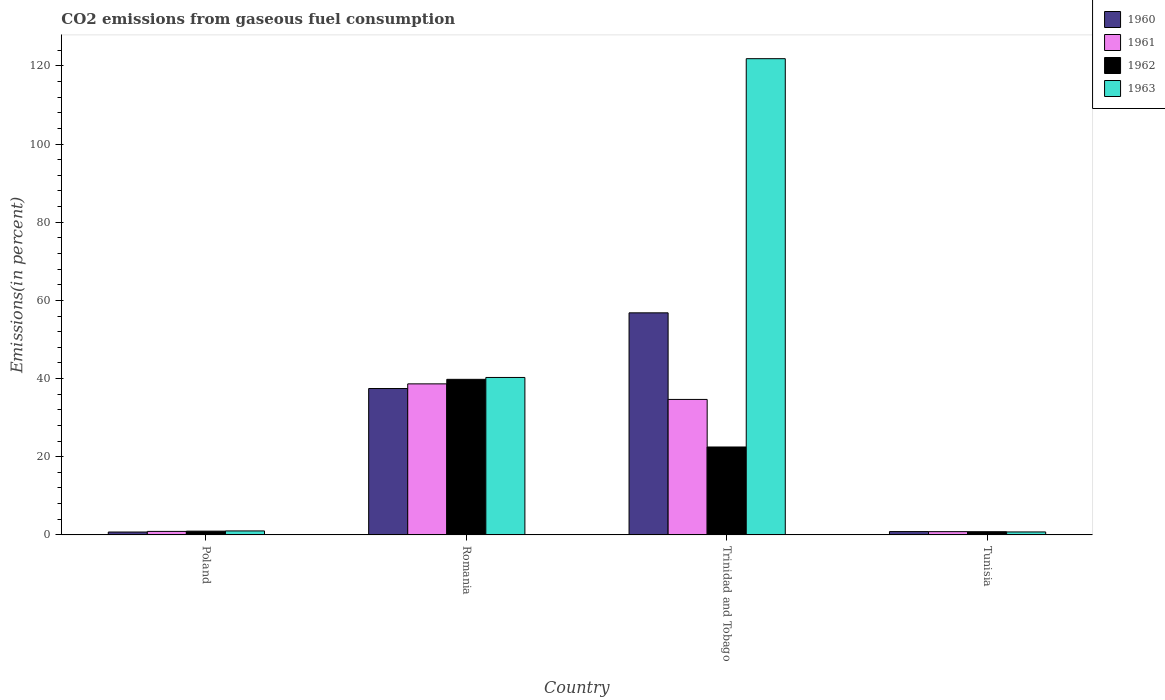How many different coloured bars are there?
Offer a very short reply. 4. How many groups of bars are there?
Offer a terse response. 4. Are the number of bars per tick equal to the number of legend labels?
Your answer should be compact. Yes. How many bars are there on the 1st tick from the right?
Give a very brief answer. 4. What is the label of the 3rd group of bars from the left?
Offer a terse response. Trinidad and Tobago. In how many cases, is the number of bars for a given country not equal to the number of legend labels?
Offer a very short reply. 0. What is the total CO2 emitted in 1963 in Trinidad and Tobago?
Offer a very short reply. 121.85. Across all countries, what is the maximum total CO2 emitted in 1961?
Ensure brevity in your answer.  38.65. Across all countries, what is the minimum total CO2 emitted in 1962?
Your response must be concise. 0.82. In which country was the total CO2 emitted in 1960 maximum?
Your answer should be very brief. Trinidad and Tobago. In which country was the total CO2 emitted in 1962 minimum?
Your answer should be compact. Tunisia. What is the total total CO2 emitted in 1962 in the graph?
Your answer should be very brief. 64.07. What is the difference between the total CO2 emitted in 1962 in Poland and that in Tunisia?
Your answer should be compact. 0.14. What is the difference between the total CO2 emitted in 1961 in Trinidad and Tobago and the total CO2 emitted in 1963 in Romania?
Your response must be concise. -5.62. What is the average total CO2 emitted in 1962 per country?
Offer a very short reply. 16.02. What is the difference between the total CO2 emitted of/in 1963 and total CO2 emitted of/in 1961 in Tunisia?
Your answer should be very brief. -0.08. What is the ratio of the total CO2 emitted in 1963 in Trinidad and Tobago to that in Tunisia?
Offer a terse response. 161.75. What is the difference between the highest and the second highest total CO2 emitted in 1960?
Your response must be concise. 55.97. What is the difference between the highest and the lowest total CO2 emitted in 1960?
Your response must be concise. 56.08. In how many countries, is the total CO2 emitted in 1962 greater than the average total CO2 emitted in 1962 taken over all countries?
Your answer should be very brief. 2. Is it the case that in every country, the sum of the total CO2 emitted in 1961 and total CO2 emitted in 1962 is greater than the sum of total CO2 emitted in 1963 and total CO2 emitted in 1960?
Keep it short and to the point. No. What does the 4th bar from the left in Tunisia represents?
Keep it short and to the point. 1963. What does the 3rd bar from the right in Tunisia represents?
Keep it short and to the point. 1961. How many bars are there?
Keep it short and to the point. 16. Are all the bars in the graph horizontal?
Offer a terse response. No. How many countries are there in the graph?
Your response must be concise. 4. Are the values on the major ticks of Y-axis written in scientific E-notation?
Make the answer very short. No. Does the graph contain any zero values?
Make the answer very short. No. Where does the legend appear in the graph?
Your response must be concise. Top right. What is the title of the graph?
Give a very brief answer. CO2 emissions from gaseous fuel consumption. Does "1982" appear as one of the legend labels in the graph?
Your response must be concise. No. What is the label or title of the Y-axis?
Provide a succinct answer. Emissions(in percent). What is the Emissions(in percent) in 1960 in Poland?
Give a very brief answer. 0.74. What is the Emissions(in percent) of 1961 in Poland?
Ensure brevity in your answer.  0.89. What is the Emissions(in percent) in 1962 in Poland?
Give a very brief answer. 0.96. What is the Emissions(in percent) of 1963 in Poland?
Make the answer very short. 1.01. What is the Emissions(in percent) of 1960 in Romania?
Keep it short and to the point. 37.45. What is the Emissions(in percent) in 1961 in Romania?
Offer a very short reply. 38.65. What is the Emissions(in percent) of 1962 in Romania?
Your answer should be compact. 39.8. What is the Emissions(in percent) of 1963 in Romania?
Offer a very short reply. 40.28. What is the Emissions(in percent) in 1960 in Trinidad and Tobago?
Provide a succinct answer. 56.82. What is the Emissions(in percent) of 1961 in Trinidad and Tobago?
Provide a short and direct response. 34.66. What is the Emissions(in percent) in 1962 in Trinidad and Tobago?
Offer a very short reply. 22.49. What is the Emissions(in percent) of 1963 in Trinidad and Tobago?
Ensure brevity in your answer.  121.85. What is the Emissions(in percent) of 1960 in Tunisia?
Offer a terse response. 0.85. What is the Emissions(in percent) of 1961 in Tunisia?
Give a very brief answer. 0.83. What is the Emissions(in percent) in 1962 in Tunisia?
Make the answer very short. 0.82. What is the Emissions(in percent) of 1963 in Tunisia?
Make the answer very short. 0.75. Across all countries, what is the maximum Emissions(in percent) in 1960?
Ensure brevity in your answer.  56.82. Across all countries, what is the maximum Emissions(in percent) in 1961?
Your answer should be very brief. 38.65. Across all countries, what is the maximum Emissions(in percent) of 1962?
Your answer should be very brief. 39.8. Across all countries, what is the maximum Emissions(in percent) in 1963?
Your answer should be compact. 121.85. Across all countries, what is the minimum Emissions(in percent) in 1960?
Offer a terse response. 0.74. Across all countries, what is the minimum Emissions(in percent) in 1961?
Your response must be concise. 0.83. Across all countries, what is the minimum Emissions(in percent) of 1962?
Make the answer very short. 0.82. Across all countries, what is the minimum Emissions(in percent) in 1963?
Your response must be concise. 0.75. What is the total Emissions(in percent) of 1960 in the graph?
Offer a very short reply. 95.86. What is the total Emissions(in percent) in 1961 in the graph?
Your response must be concise. 75.03. What is the total Emissions(in percent) in 1962 in the graph?
Provide a succinct answer. 64.07. What is the total Emissions(in percent) in 1963 in the graph?
Offer a terse response. 163.9. What is the difference between the Emissions(in percent) in 1960 in Poland and that in Romania?
Provide a short and direct response. -36.72. What is the difference between the Emissions(in percent) of 1961 in Poland and that in Romania?
Offer a terse response. -37.75. What is the difference between the Emissions(in percent) of 1962 in Poland and that in Romania?
Your answer should be compact. -38.85. What is the difference between the Emissions(in percent) in 1963 in Poland and that in Romania?
Offer a terse response. -39.27. What is the difference between the Emissions(in percent) of 1960 in Poland and that in Trinidad and Tobago?
Keep it short and to the point. -56.08. What is the difference between the Emissions(in percent) in 1961 in Poland and that in Trinidad and Tobago?
Offer a terse response. -33.77. What is the difference between the Emissions(in percent) in 1962 in Poland and that in Trinidad and Tobago?
Give a very brief answer. -21.53. What is the difference between the Emissions(in percent) in 1963 in Poland and that in Trinidad and Tobago?
Keep it short and to the point. -120.84. What is the difference between the Emissions(in percent) in 1960 in Poland and that in Tunisia?
Your answer should be compact. -0.11. What is the difference between the Emissions(in percent) in 1961 in Poland and that in Tunisia?
Your answer should be compact. 0.06. What is the difference between the Emissions(in percent) in 1962 in Poland and that in Tunisia?
Make the answer very short. 0.14. What is the difference between the Emissions(in percent) in 1963 in Poland and that in Tunisia?
Your answer should be very brief. 0.26. What is the difference between the Emissions(in percent) in 1960 in Romania and that in Trinidad and Tobago?
Provide a succinct answer. -19.37. What is the difference between the Emissions(in percent) of 1961 in Romania and that in Trinidad and Tobago?
Your answer should be compact. 3.98. What is the difference between the Emissions(in percent) of 1962 in Romania and that in Trinidad and Tobago?
Keep it short and to the point. 17.31. What is the difference between the Emissions(in percent) in 1963 in Romania and that in Trinidad and Tobago?
Ensure brevity in your answer.  -81.57. What is the difference between the Emissions(in percent) in 1960 in Romania and that in Tunisia?
Keep it short and to the point. 36.6. What is the difference between the Emissions(in percent) in 1961 in Romania and that in Tunisia?
Your answer should be very brief. 37.82. What is the difference between the Emissions(in percent) in 1962 in Romania and that in Tunisia?
Your response must be concise. 38.99. What is the difference between the Emissions(in percent) in 1963 in Romania and that in Tunisia?
Ensure brevity in your answer.  39.53. What is the difference between the Emissions(in percent) of 1960 in Trinidad and Tobago and that in Tunisia?
Keep it short and to the point. 55.97. What is the difference between the Emissions(in percent) of 1961 in Trinidad and Tobago and that in Tunisia?
Keep it short and to the point. 33.83. What is the difference between the Emissions(in percent) in 1962 in Trinidad and Tobago and that in Tunisia?
Provide a short and direct response. 21.68. What is the difference between the Emissions(in percent) in 1963 in Trinidad and Tobago and that in Tunisia?
Keep it short and to the point. 121.1. What is the difference between the Emissions(in percent) in 1960 in Poland and the Emissions(in percent) in 1961 in Romania?
Provide a succinct answer. -37.91. What is the difference between the Emissions(in percent) in 1960 in Poland and the Emissions(in percent) in 1962 in Romania?
Give a very brief answer. -39.07. What is the difference between the Emissions(in percent) in 1960 in Poland and the Emissions(in percent) in 1963 in Romania?
Provide a short and direct response. -39.55. What is the difference between the Emissions(in percent) of 1961 in Poland and the Emissions(in percent) of 1962 in Romania?
Make the answer very short. -38.91. What is the difference between the Emissions(in percent) in 1961 in Poland and the Emissions(in percent) in 1963 in Romania?
Keep it short and to the point. -39.39. What is the difference between the Emissions(in percent) of 1962 in Poland and the Emissions(in percent) of 1963 in Romania?
Your response must be concise. -39.32. What is the difference between the Emissions(in percent) in 1960 in Poland and the Emissions(in percent) in 1961 in Trinidad and Tobago?
Offer a very short reply. -33.93. What is the difference between the Emissions(in percent) of 1960 in Poland and the Emissions(in percent) of 1962 in Trinidad and Tobago?
Give a very brief answer. -21.76. What is the difference between the Emissions(in percent) of 1960 in Poland and the Emissions(in percent) of 1963 in Trinidad and Tobago?
Your answer should be compact. -121.11. What is the difference between the Emissions(in percent) of 1961 in Poland and the Emissions(in percent) of 1962 in Trinidad and Tobago?
Keep it short and to the point. -21.6. What is the difference between the Emissions(in percent) of 1961 in Poland and the Emissions(in percent) of 1963 in Trinidad and Tobago?
Offer a very short reply. -120.95. What is the difference between the Emissions(in percent) in 1962 in Poland and the Emissions(in percent) in 1963 in Trinidad and Tobago?
Provide a short and direct response. -120.89. What is the difference between the Emissions(in percent) of 1960 in Poland and the Emissions(in percent) of 1961 in Tunisia?
Ensure brevity in your answer.  -0.09. What is the difference between the Emissions(in percent) in 1960 in Poland and the Emissions(in percent) in 1962 in Tunisia?
Ensure brevity in your answer.  -0.08. What is the difference between the Emissions(in percent) in 1960 in Poland and the Emissions(in percent) in 1963 in Tunisia?
Offer a very short reply. -0.02. What is the difference between the Emissions(in percent) in 1961 in Poland and the Emissions(in percent) in 1962 in Tunisia?
Your answer should be very brief. 0.08. What is the difference between the Emissions(in percent) of 1961 in Poland and the Emissions(in percent) of 1963 in Tunisia?
Your answer should be compact. 0.14. What is the difference between the Emissions(in percent) of 1962 in Poland and the Emissions(in percent) of 1963 in Tunisia?
Give a very brief answer. 0.21. What is the difference between the Emissions(in percent) of 1960 in Romania and the Emissions(in percent) of 1961 in Trinidad and Tobago?
Make the answer very short. 2.79. What is the difference between the Emissions(in percent) of 1960 in Romania and the Emissions(in percent) of 1962 in Trinidad and Tobago?
Provide a succinct answer. 14.96. What is the difference between the Emissions(in percent) in 1960 in Romania and the Emissions(in percent) in 1963 in Trinidad and Tobago?
Provide a short and direct response. -84.4. What is the difference between the Emissions(in percent) of 1961 in Romania and the Emissions(in percent) of 1962 in Trinidad and Tobago?
Ensure brevity in your answer.  16.15. What is the difference between the Emissions(in percent) in 1961 in Romania and the Emissions(in percent) in 1963 in Trinidad and Tobago?
Provide a short and direct response. -83.2. What is the difference between the Emissions(in percent) in 1962 in Romania and the Emissions(in percent) in 1963 in Trinidad and Tobago?
Make the answer very short. -82.04. What is the difference between the Emissions(in percent) of 1960 in Romania and the Emissions(in percent) of 1961 in Tunisia?
Keep it short and to the point. 36.62. What is the difference between the Emissions(in percent) in 1960 in Romania and the Emissions(in percent) in 1962 in Tunisia?
Provide a short and direct response. 36.64. What is the difference between the Emissions(in percent) in 1960 in Romania and the Emissions(in percent) in 1963 in Tunisia?
Provide a succinct answer. 36.7. What is the difference between the Emissions(in percent) in 1961 in Romania and the Emissions(in percent) in 1962 in Tunisia?
Offer a terse response. 37.83. What is the difference between the Emissions(in percent) in 1961 in Romania and the Emissions(in percent) in 1963 in Tunisia?
Your answer should be compact. 37.89. What is the difference between the Emissions(in percent) in 1962 in Romania and the Emissions(in percent) in 1963 in Tunisia?
Your response must be concise. 39.05. What is the difference between the Emissions(in percent) in 1960 in Trinidad and Tobago and the Emissions(in percent) in 1961 in Tunisia?
Your answer should be compact. 55.99. What is the difference between the Emissions(in percent) of 1960 in Trinidad and Tobago and the Emissions(in percent) of 1962 in Tunisia?
Your response must be concise. 56. What is the difference between the Emissions(in percent) in 1960 in Trinidad and Tobago and the Emissions(in percent) in 1963 in Tunisia?
Your response must be concise. 56.06. What is the difference between the Emissions(in percent) in 1961 in Trinidad and Tobago and the Emissions(in percent) in 1962 in Tunisia?
Offer a very short reply. 33.84. What is the difference between the Emissions(in percent) of 1961 in Trinidad and Tobago and the Emissions(in percent) of 1963 in Tunisia?
Ensure brevity in your answer.  33.91. What is the difference between the Emissions(in percent) in 1962 in Trinidad and Tobago and the Emissions(in percent) in 1963 in Tunisia?
Provide a short and direct response. 21.74. What is the average Emissions(in percent) of 1960 per country?
Offer a terse response. 23.96. What is the average Emissions(in percent) in 1961 per country?
Keep it short and to the point. 18.76. What is the average Emissions(in percent) in 1962 per country?
Offer a terse response. 16.02. What is the average Emissions(in percent) of 1963 per country?
Provide a short and direct response. 40.97. What is the difference between the Emissions(in percent) in 1960 and Emissions(in percent) in 1961 in Poland?
Provide a succinct answer. -0.16. What is the difference between the Emissions(in percent) in 1960 and Emissions(in percent) in 1962 in Poland?
Give a very brief answer. -0.22. What is the difference between the Emissions(in percent) of 1960 and Emissions(in percent) of 1963 in Poland?
Provide a short and direct response. -0.28. What is the difference between the Emissions(in percent) of 1961 and Emissions(in percent) of 1962 in Poland?
Give a very brief answer. -0.06. What is the difference between the Emissions(in percent) in 1961 and Emissions(in percent) in 1963 in Poland?
Provide a succinct answer. -0.12. What is the difference between the Emissions(in percent) in 1962 and Emissions(in percent) in 1963 in Poland?
Your answer should be very brief. -0.05. What is the difference between the Emissions(in percent) of 1960 and Emissions(in percent) of 1961 in Romania?
Make the answer very short. -1.19. What is the difference between the Emissions(in percent) of 1960 and Emissions(in percent) of 1962 in Romania?
Your response must be concise. -2.35. What is the difference between the Emissions(in percent) in 1960 and Emissions(in percent) in 1963 in Romania?
Your answer should be very brief. -2.83. What is the difference between the Emissions(in percent) of 1961 and Emissions(in percent) of 1962 in Romania?
Ensure brevity in your answer.  -1.16. What is the difference between the Emissions(in percent) in 1961 and Emissions(in percent) in 1963 in Romania?
Offer a terse response. -1.64. What is the difference between the Emissions(in percent) in 1962 and Emissions(in percent) in 1963 in Romania?
Provide a succinct answer. -0.48. What is the difference between the Emissions(in percent) in 1960 and Emissions(in percent) in 1961 in Trinidad and Tobago?
Your answer should be very brief. 22.16. What is the difference between the Emissions(in percent) in 1960 and Emissions(in percent) in 1962 in Trinidad and Tobago?
Provide a succinct answer. 34.33. What is the difference between the Emissions(in percent) of 1960 and Emissions(in percent) of 1963 in Trinidad and Tobago?
Ensure brevity in your answer.  -65.03. What is the difference between the Emissions(in percent) of 1961 and Emissions(in percent) of 1962 in Trinidad and Tobago?
Your answer should be compact. 12.17. What is the difference between the Emissions(in percent) of 1961 and Emissions(in percent) of 1963 in Trinidad and Tobago?
Your answer should be compact. -87.19. What is the difference between the Emissions(in percent) in 1962 and Emissions(in percent) in 1963 in Trinidad and Tobago?
Keep it short and to the point. -99.36. What is the difference between the Emissions(in percent) of 1960 and Emissions(in percent) of 1961 in Tunisia?
Provide a short and direct response. 0.02. What is the difference between the Emissions(in percent) in 1960 and Emissions(in percent) in 1962 in Tunisia?
Your answer should be very brief. 0.03. What is the difference between the Emissions(in percent) of 1960 and Emissions(in percent) of 1963 in Tunisia?
Keep it short and to the point. 0.1. What is the difference between the Emissions(in percent) in 1961 and Emissions(in percent) in 1962 in Tunisia?
Your answer should be compact. 0.01. What is the difference between the Emissions(in percent) of 1961 and Emissions(in percent) of 1963 in Tunisia?
Give a very brief answer. 0.08. What is the difference between the Emissions(in percent) in 1962 and Emissions(in percent) in 1963 in Tunisia?
Offer a very short reply. 0.06. What is the ratio of the Emissions(in percent) of 1960 in Poland to that in Romania?
Your response must be concise. 0.02. What is the ratio of the Emissions(in percent) of 1961 in Poland to that in Romania?
Keep it short and to the point. 0.02. What is the ratio of the Emissions(in percent) of 1962 in Poland to that in Romania?
Ensure brevity in your answer.  0.02. What is the ratio of the Emissions(in percent) in 1963 in Poland to that in Romania?
Make the answer very short. 0.03. What is the ratio of the Emissions(in percent) in 1960 in Poland to that in Trinidad and Tobago?
Provide a succinct answer. 0.01. What is the ratio of the Emissions(in percent) of 1961 in Poland to that in Trinidad and Tobago?
Your response must be concise. 0.03. What is the ratio of the Emissions(in percent) in 1962 in Poland to that in Trinidad and Tobago?
Ensure brevity in your answer.  0.04. What is the ratio of the Emissions(in percent) in 1963 in Poland to that in Trinidad and Tobago?
Keep it short and to the point. 0.01. What is the ratio of the Emissions(in percent) of 1960 in Poland to that in Tunisia?
Offer a very short reply. 0.87. What is the ratio of the Emissions(in percent) of 1961 in Poland to that in Tunisia?
Offer a terse response. 1.08. What is the ratio of the Emissions(in percent) of 1962 in Poland to that in Tunisia?
Make the answer very short. 1.17. What is the ratio of the Emissions(in percent) in 1963 in Poland to that in Tunisia?
Your response must be concise. 1.35. What is the ratio of the Emissions(in percent) in 1960 in Romania to that in Trinidad and Tobago?
Ensure brevity in your answer.  0.66. What is the ratio of the Emissions(in percent) in 1961 in Romania to that in Trinidad and Tobago?
Keep it short and to the point. 1.11. What is the ratio of the Emissions(in percent) in 1962 in Romania to that in Trinidad and Tobago?
Provide a succinct answer. 1.77. What is the ratio of the Emissions(in percent) in 1963 in Romania to that in Trinidad and Tobago?
Make the answer very short. 0.33. What is the ratio of the Emissions(in percent) of 1960 in Romania to that in Tunisia?
Make the answer very short. 44.1. What is the ratio of the Emissions(in percent) of 1961 in Romania to that in Tunisia?
Your answer should be very brief. 46.57. What is the ratio of the Emissions(in percent) of 1962 in Romania to that in Tunisia?
Provide a succinct answer. 48.76. What is the ratio of the Emissions(in percent) in 1963 in Romania to that in Tunisia?
Make the answer very short. 53.48. What is the ratio of the Emissions(in percent) of 1960 in Trinidad and Tobago to that in Tunisia?
Make the answer very short. 66.9. What is the ratio of the Emissions(in percent) in 1961 in Trinidad and Tobago to that in Tunisia?
Give a very brief answer. 41.77. What is the ratio of the Emissions(in percent) of 1962 in Trinidad and Tobago to that in Tunisia?
Provide a succinct answer. 27.55. What is the ratio of the Emissions(in percent) of 1963 in Trinidad and Tobago to that in Tunisia?
Your answer should be compact. 161.75. What is the difference between the highest and the second highest Emissions(in percent) of 1960?
Offer a terse response. 19.37. What is the difference between the highest and the second highest Emissions(in percent) of 1961?
Make the answer very short. 3.98. What is the difference between the highest and the second highest Emissions(in percent) in 1962?
Your answer should be very brief. 17.31. What is the difference between the highest and the second highest Emissions(in percent) of 1963?
Your response must be concise. 81.57. What is the difference between the highest and the lowest Emissions(in percent) of 1960?
Your answer should be very brief. 56.08. What is the difference between the highest and the lowest Emissions(in percent) of 1961?
Provide a succinct answer. 37.82. What is the difference between the highest and the lowest Emissions(in percent) of 1962?
Give a very brief answer. 38.99. What is the difference between the highest and the lowest Emissions(in percent) in 1963?
Make the answer very short. 121.1. 